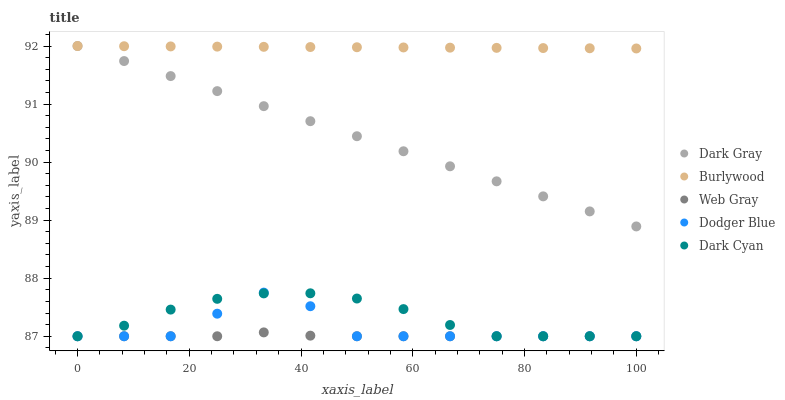Does Web Gray have the minimum area under the curve?
Answer yes or no. Yes. Does Burlywood have the maximum area under the curve?
Answer yes or no. Yes. Does Burlywood have the minimum area under the curve?
Answer yes or no. No. Does Web Gray have the maximum area under the curve?
Answer yes or no. No. Is Dark Gray the smoothest?
Answer yes or no. Yes. Is Dodger Blue the roughest?
Answer yes or no. Yes. Is Burlywood the smoothest?
Answer yes or no. No. Is Burlywood the roughest?
Answer yes or no. No. Does Web Gray have the lowest value?
Answer yes or no. Yes. Does Burlywood have the lowest value?
Answer yes or no. No. Does Burlywood have the highest value?
Answer yes or no. Yes. Does Web Gray have the highest value?
Answer yes or no. No. Is Dark Cyan less than Dark Gray?
Answer yes or no. Yes. Is Burlywood greater than Dodger Blue?
Answer yes or no. Yes. Does Web Gray intersect Dodger Blue?
Answer yes or no. Yes. Is Web Gray less than Dodger Blue?
Answer yes or no. No. Is Web Gray greater than Dodger Blue?
Answer yes or no. No. Does Dark Cyan intersect Dark Gray?
Answer yes or no. No. 